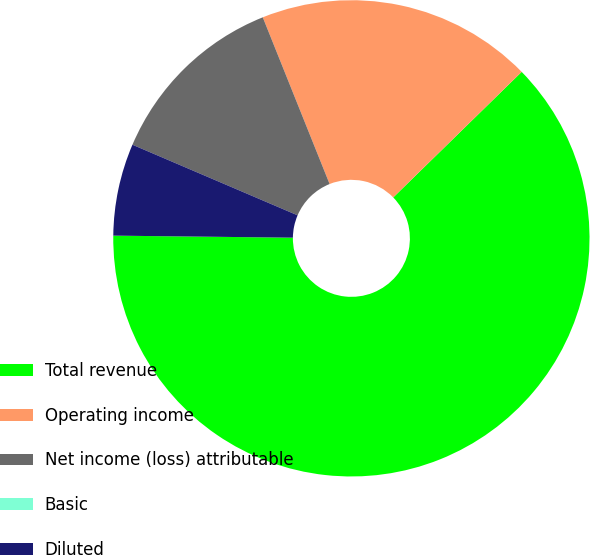<chart> <loc_0><loc_0><loc_500><loc_500><pie_chart><fcel>Total revenue<fcel>Operating income<fcel>Net income (loss) attributable<fcel>Basic<fcel>Diluted<nl><fcel>62.5%<fcel>18.75%<fcel>12.5%<fcel>0.0%<fcel>6.25%<nl></chart> 